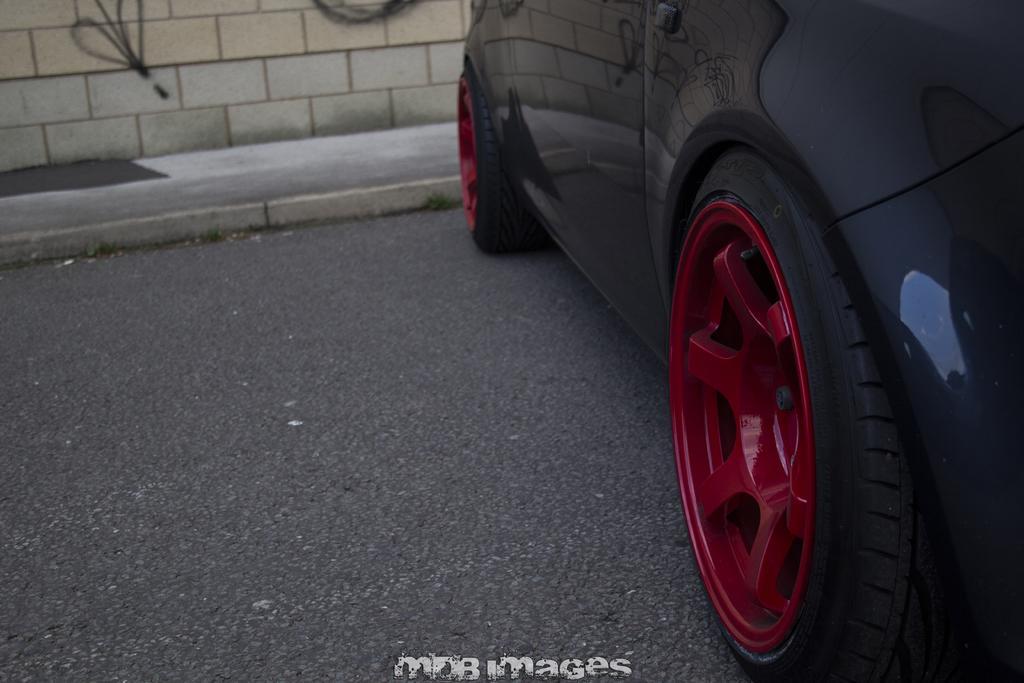In one or two sentences, can you explain what this image depicts? In this picture we can see a car on the path. There is some text visible at the bottom of the picture. We can see a wall in the background. 